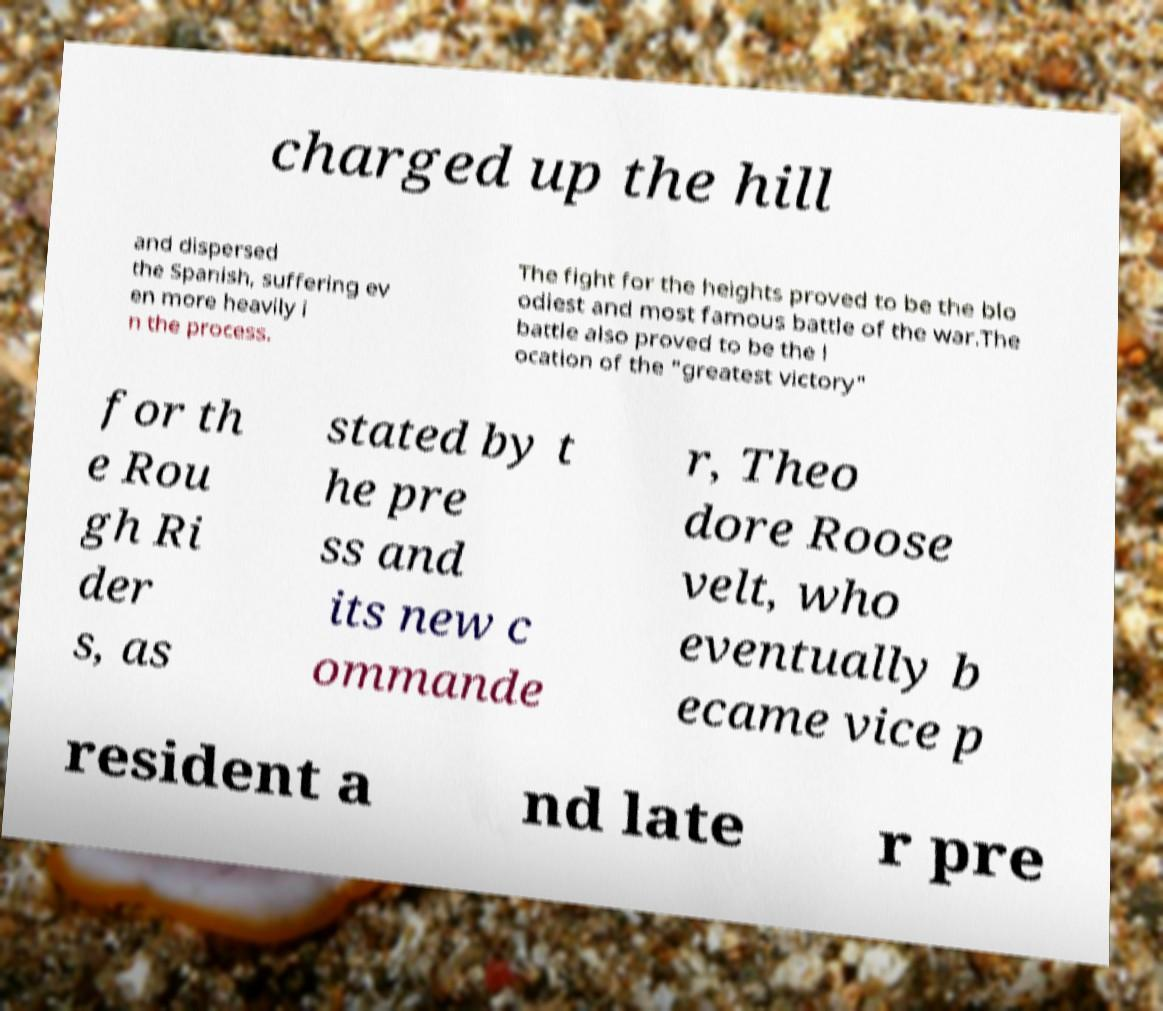Can you accurately transcribe the text from the provided image for me? charged up the hill and dispersed the Spanish, suffering ev en more heavily i n the process. The fight for the heights proved to be the blo odiest and most famous battle of the war.The battle also proved to be the l ocation of the "greatest victory" for th e Rou gh Ri der s, as stated by t he pre ss and its new c ommande r, Theo dore Roose velt, who eventually b ecame vice p resident a nd late r pre 